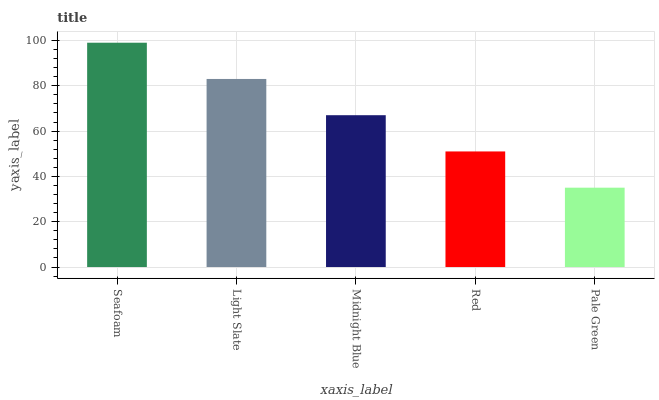Is Pale Green the minimum?
Answer yes or no. Yes. Is Seafoam the maximum?
Answer yes or no. Yes. Is Light Slate the minimum?
Answer yes or no. No. Is Light Slate the maximum?
Answer yes or no. No. Is Seafoam greater than Light Slate?
Answer yes or no. Yes. Is Light Slate less than Seafoam?
Answer yes or no. Yes. Is Light Slate greater than Seafoam?
Answer yes or no. No. Is Seafoam less than Light Slate?
Answer yes or no. No. Is Midnight Blue the high median?
Answer yes or no. Yes. Is Midnight Blue the low median?
Answer yes or no. Yes. Is Seafoam the high median?
Answer yes or no. No. Is Light Slate the low median?
Answer yes or no. No. 